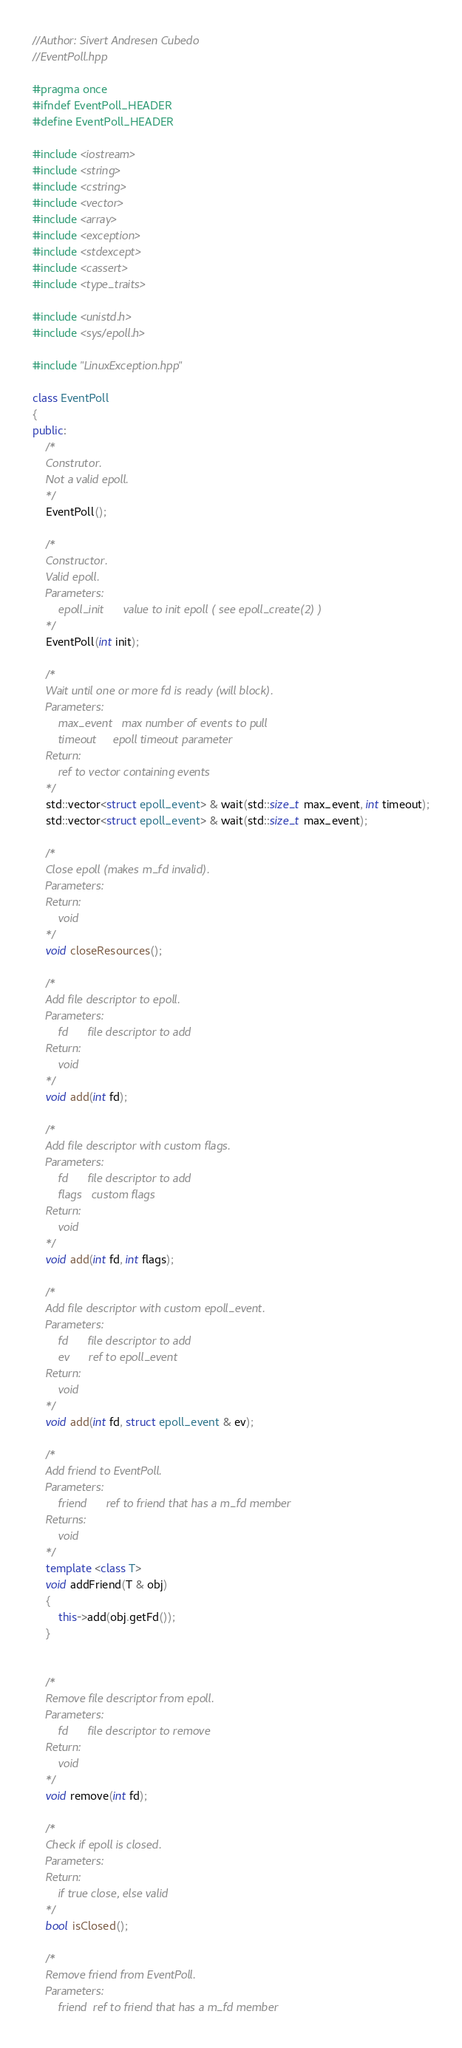<code> <loc_0><loc_0><loc_500><loc_500><_C++_>//Author: Sivert Andresen Cubedo
//EventPoll.hpp

#pragma once
#ifndef EventPoll_HEADER
#define EventPoll_HEADER

#include <iostream>
#include <string>
#include <cstring>
#include <vector>
#include <array>
#include <exception>
#include <stdexcept>
#include <cassert>
#include <type_traits>

#include <unistd.h>
#include <sys/epoll.h>

#include "LinuxException.hpp"

class EventPoll
{
public:
	/*
	Construtor.
	Not a valid epoll.
	*/
	EventPoll();
	
	/*
	Constructor.
	Valid epoll.
	Parameters:
		epoll_init		value to init epoll ( see epoll_create(2) )
	*/
	EventPoll(int init);

	/*
	Wait until one or more fd is ready (will block).
	Parameters:
		max_event	max number of events to pull
		timeout		epoll timeout parameter
	Return:
		ref to vector containing events
	*/
	std::vector<struct epoll_event> & wait(std::size_t max_event, int timeout);
	std::vector<struct epoll_event> & wait(std::size_t max_event);

	/*
	Close epoll (makes m_fd invalid).
	Parameters:
	Return:
		void
	*/
	void closeResources();

	/*
	Add file descriptor to epoll.
	Parameters:
		fd		file descriptor to add
	Return:
		void
	*/
	void add(int fd);

	/*
	Add file descriptor with custom flags.
	Parameters:
		fd		file descriptor to add
		flags	custom flags
	Return:
		void
	*/
	void add(int fd, int flags);

	/*
	Add file descriptor with custom epoll_event.
	Parameters:
		fd		file descriptor to add
		ev		ref to epoll_event
	Return:
		void
	*/
	void add(int fd, struct epoll_event & ev);

	/*
	Add friend to EventPoll.
	Parameters:
		friend		ref to friend that has a m_fd member
	Returns:
		void
	*/
	template <class T>
	void addFriend(T & obj)
	{
		this->add(obj.getFd());
	}
	

	/*
	Remove file descriptor from epoll.
	Parameters:
		fd		file descriptor to remove
	Return:
		void
	*/
	void remove(int fd);

	/*
	Check if epoll is closed.
	Parameters:
	Return:
		if true close, else valid
	*/
	bool isClosed();

	/*
	Remove friend from EventPoll.
	Parameters:
		friend	ref to friend that has a m_fd member</code> 